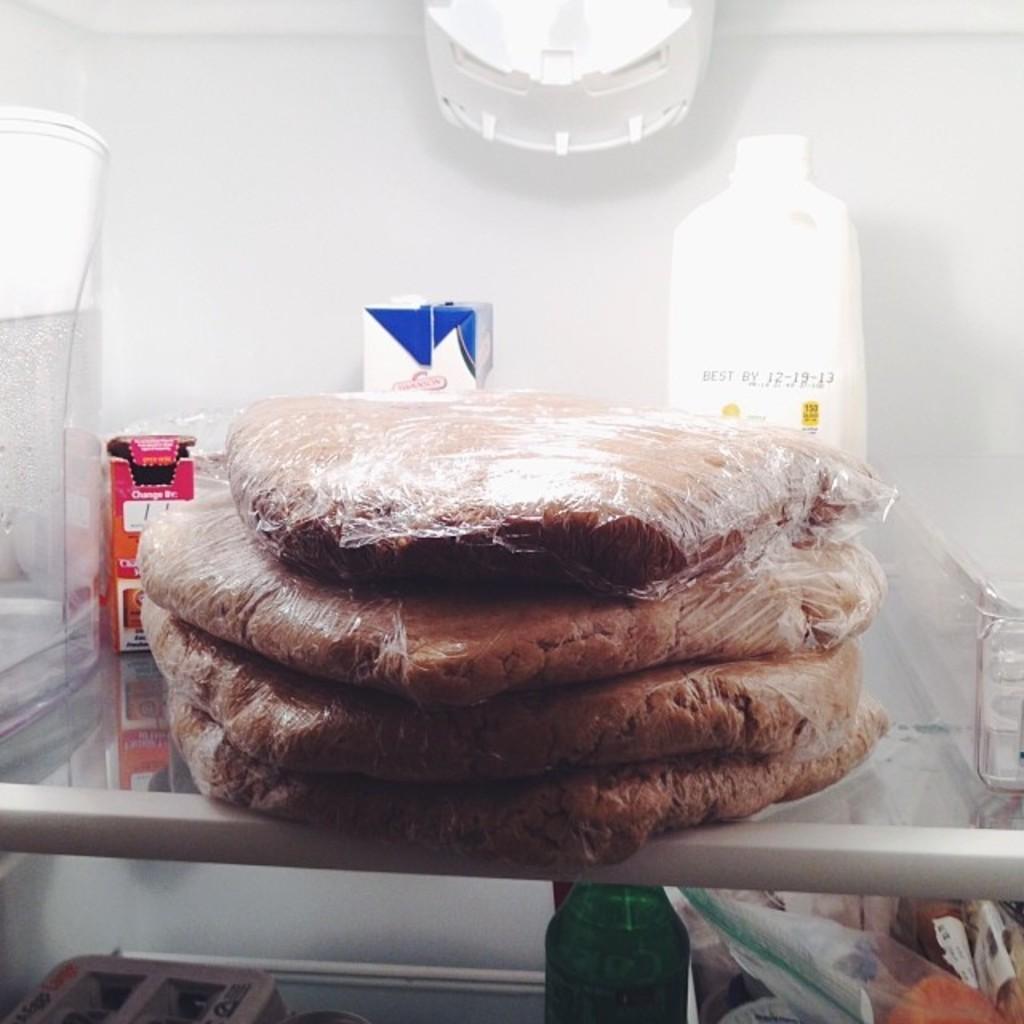Can you describe this image briefly? This is a picture of the inside of the fridge. In this picture in the middle there are some food items, and on the background there is a bottle and some food packets are there and in the bottom there is a bottle there is some food items are there. 